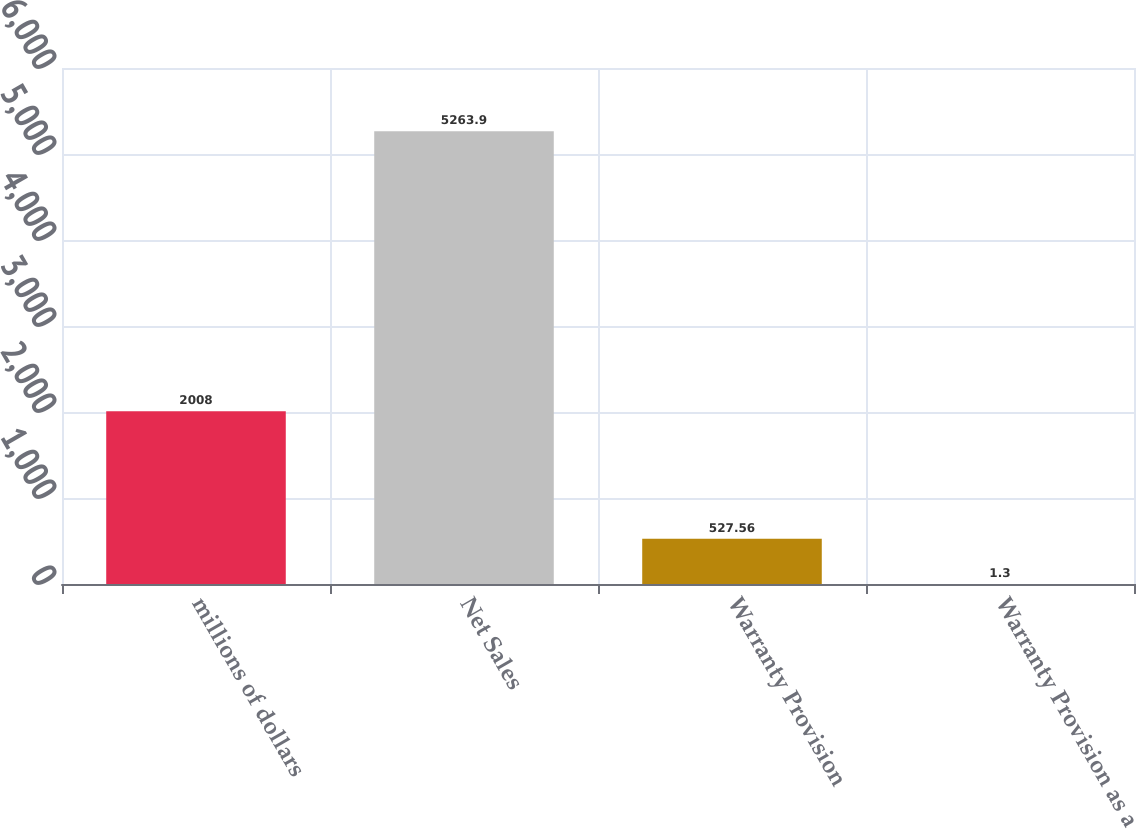Convert chart. <chart><loc_0><loc_0><loc_500><loc_500><bar_chart><fcel>millions of dollars<fcel>Net Sales<fcel>Warranty Provision<fcel>Warranty Provision as a<nl><fcel>2008<fcel>5263.9<fcel>527.56<fcel>1.3<nl></chart> 